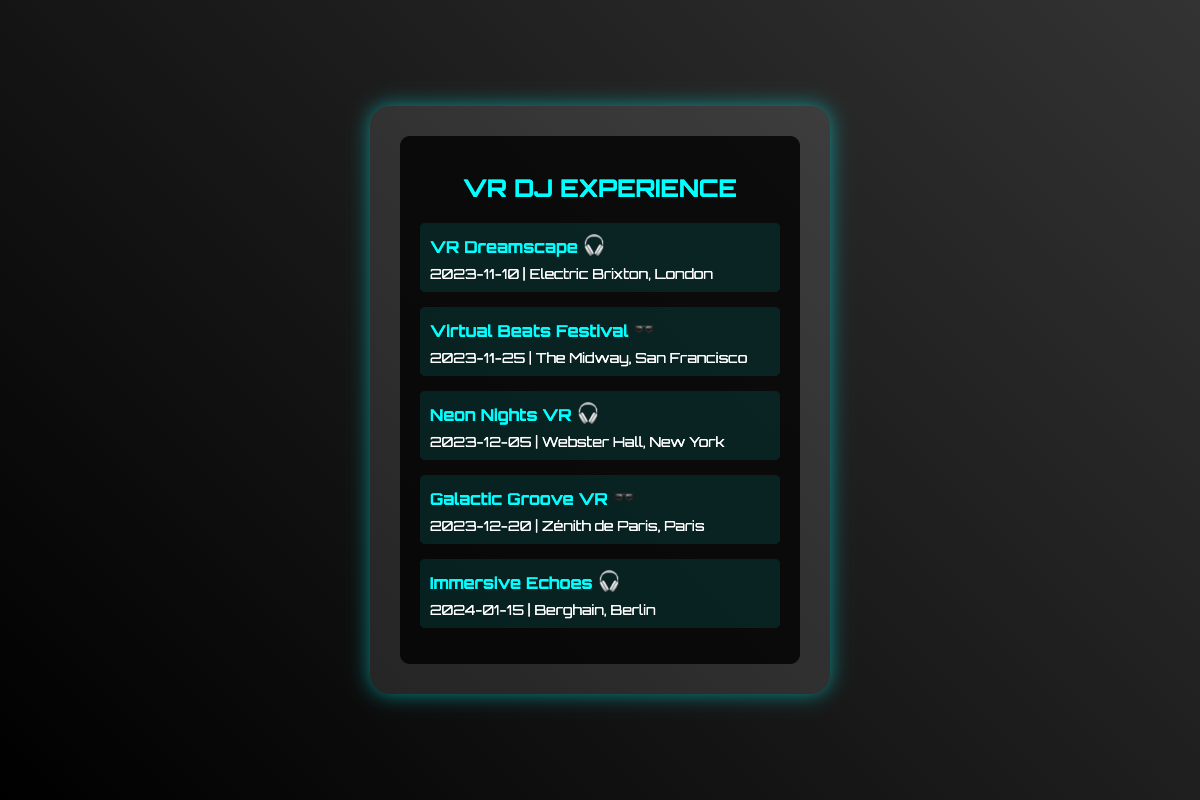What is the name of the first event? The name of the first event is listed at the top of the events list.
Answer: VR Dreamscape When is the Virtual Beats Festival scheduled? The date is mentioned alongside the event name in the document.
Answer: 2023-11-25 Which venue will host the Neon Nights VR event? The venue is provided in the event details section for each performance.
Answer: Webster Hall, New York How many events are listed in total? The number of events can be counted in the events list.
Answer: 5 What icon signifies the VR headset experience for the Galactic Groove VR event? The icon associated with the event in the list represents this feature.
Answer: 🕶️ What is the date of the last event listed? The date for the last event can be found in the event details section.
Answer: 2024-01-15 Which city is hosting the Immersive Echoes event? The city is mentioned as part of the venue details for the event.
Answer: Berlin Which event is taking place at Electric Brixton? The venue is linked to a specific event in the document.
Answer: VR Dreamscape What type of experiences does the DJ specialize in? The title of the card indicates the nature of the experiences offered.
Answer: VR Experience 